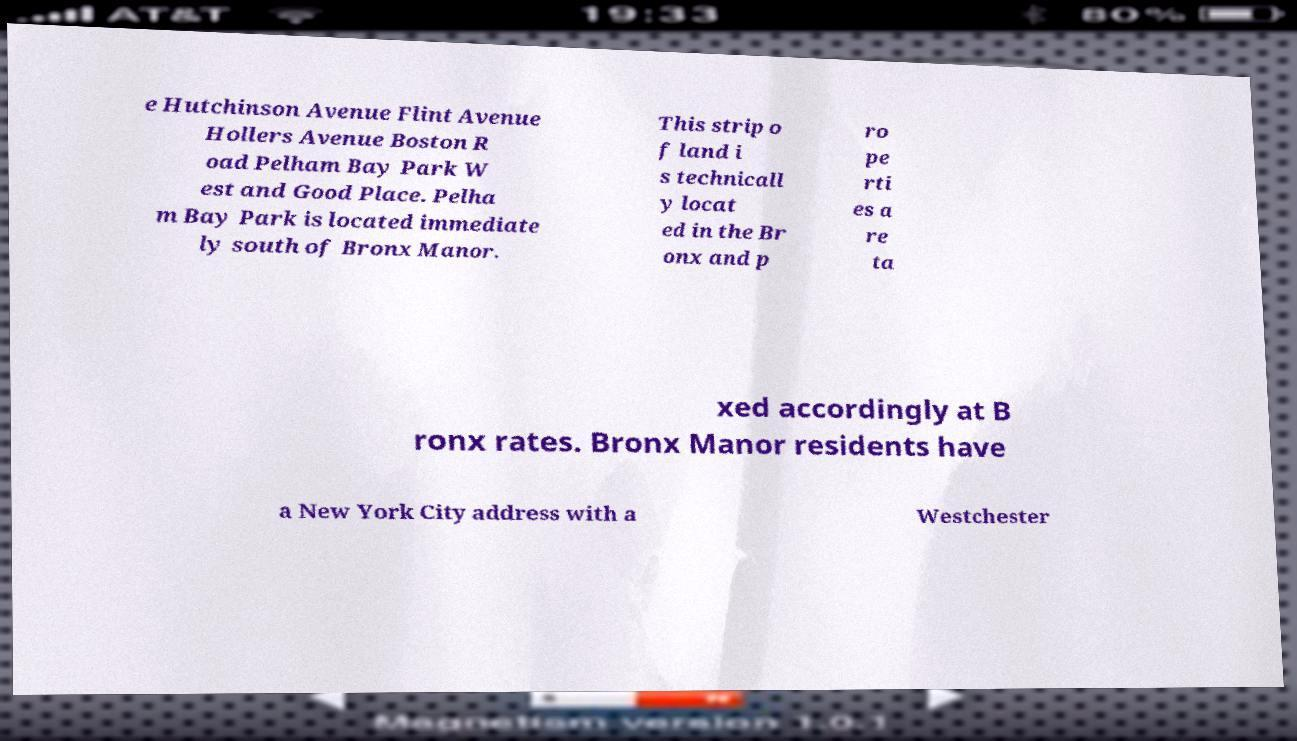Please identify and transcribe the text found in this image. e Hutchinson Avenue Flint Avenue Hollers Avenue Boston R oad Pelham Bay Park W est and Good Place. Pelha m Bay Park is located immediate ly south of Bronx Manor. This strip o f land i s technicall y locat ed in the Br onx and p ro pe rti es a re ta xed accordingly at B ronx rates. Bronx Manor residents have a New York City address with a Westchester 